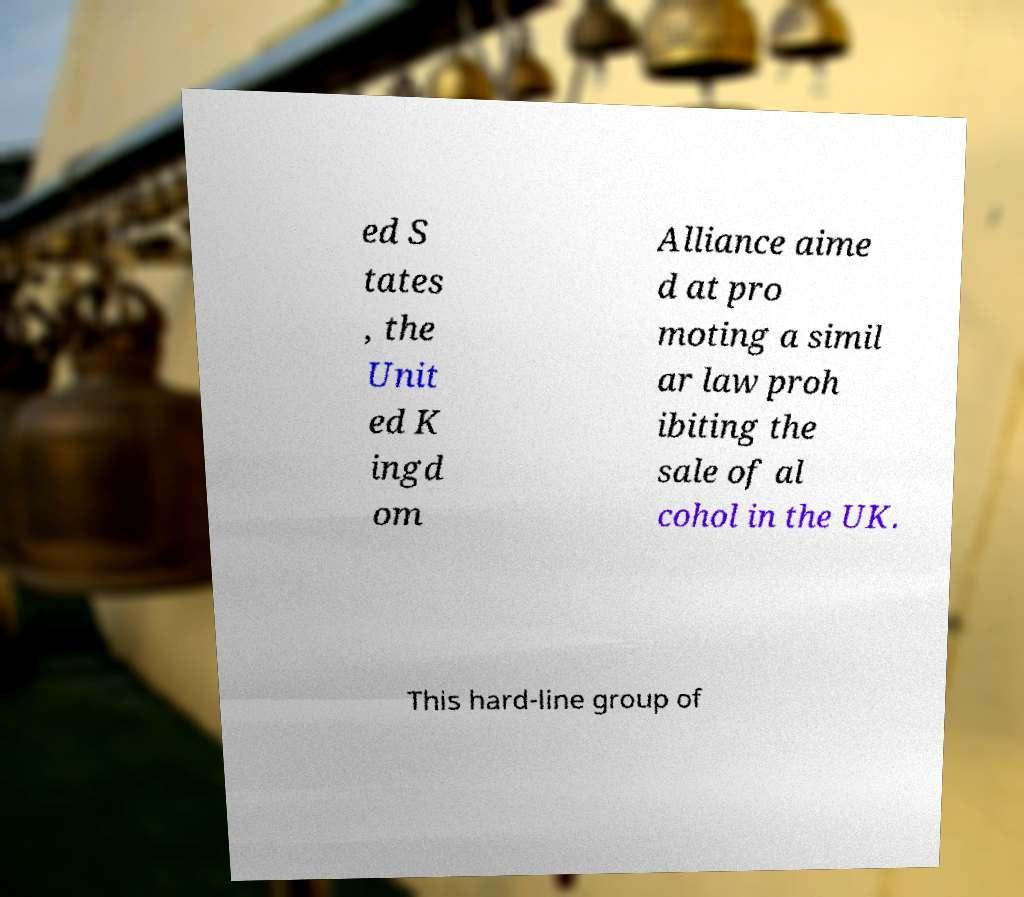For documentation purposes, I need the text within this image transcribed. Could you provide that? ed S tates , the Unit ed K ingd om Alliance aime d at pro moting a simil ar law proh ibiting the sale of al cohol in the UK. This hard-line group of 